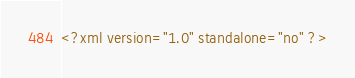Convert code to text. <code><loc_0><loc_0><loc_500><loc_500><_XML_><?xml version="1.0" standalone="no" ?></code> 